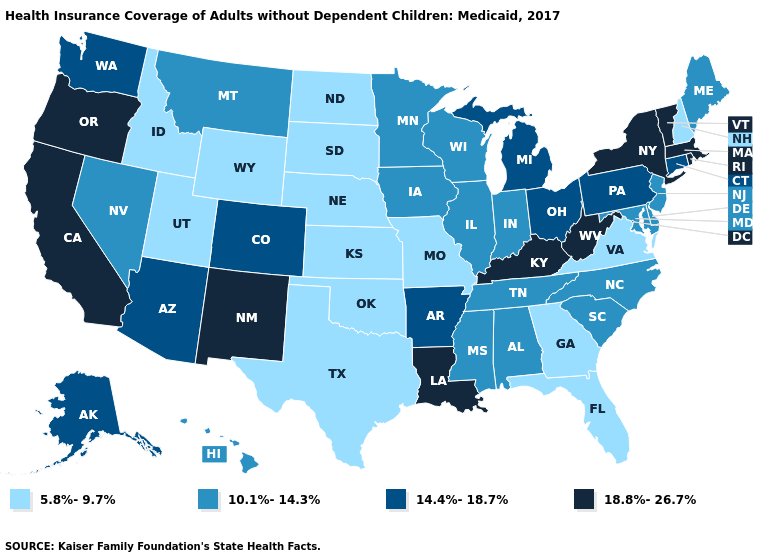Among the states that border Massachusetts , does Connecticut have the highest value?
Give a very brief answer. No. Among the states that border Utah , does New Mexico have the highest value?
Answer briefly. Yes. Name the states that have a value in the range 5.8%-9.7%?
Concise answer only. Florida, Georgia, Idaho, Kansas, Missouri, Nebraska, New Hampshire, North Dakota, Oklahoma, South Dakota, Texas, Utah, Virginia, Wyoming. Name the states that have a value in the range 10.1%-14.3%?
Concise answer only. Alabama, Delaware, Hawaii, Illinois, Indiana, Iowa, Maine, Maryland, Minnesota, Mississippi, Montana, Nevada, New Jersey, North Carolina, South Carolina, Tennessee, Wisconsin. Name the states that have a value in the range 10.1%-14.3%?
Short answer required. Alabama, Delaware, Hawaii, Illinois, Indiana, Iowa, Maine, Maryland, Minnesota, Mississippi, Montana, Nevada, New Jersey, North Carolina, South Carolina, Tennessee, Wisconsin. What is the lowest value in the West?
Keep it brief. 5.8%-9.7%. Among the states that border Vermont , which have the highest value?
Quick response, please. Massachusetts, New York. What is the lowest value in states that border Nevada?
Answer briefly. 5.8%-9.7%. What is the value of Wyoming?
Answer briefly. 5.8%-9.7%. What is the value of Georgia?
Keep it brief. 5.8%-9.7%. Name the states that have a value in the range 14.4%-18.7%?
Answer briefly. Alaska, Arizona, Arkansas, Colorado, Connecticut, Michigan, Ohio, Pennsylvania, Washington. What is the value of Nevada?
Answer briefly. 10.1%-14.3%. What is the value of Washington?
Write a very short answer. 14.4%-18.7%. What is the highest value in the MidWest ?
Answer briefly. 14.4%-18.7%. What is the lowest value in the Northeast?
Answer briefly. 5.8%-9.7%. 